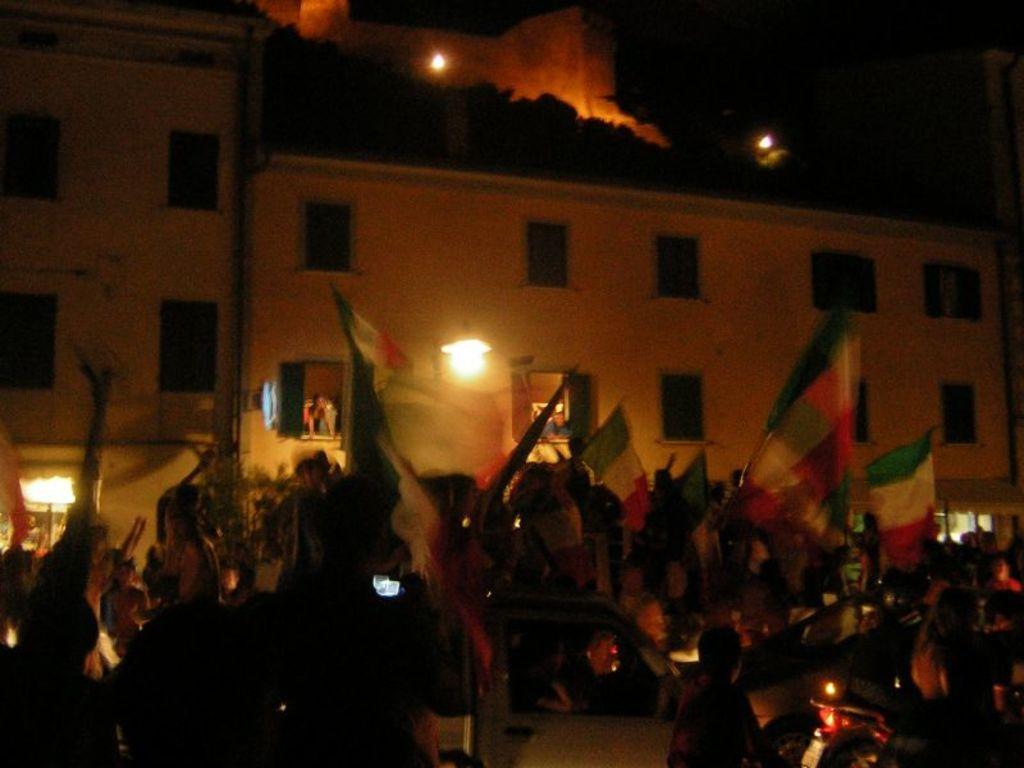Could you give a brief overview of what you see in this image? In this image there are many people in the foreground. Few are holding flags. In the background there are buildings. Here there is a light. Through the windows people are looking outside. On the top there are lights. 